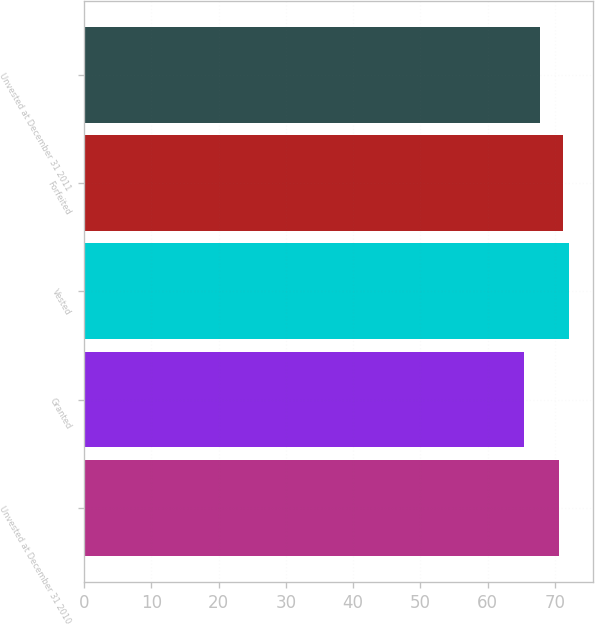Convert chart. <chart><loc_0><loc_0><loc_500><loc_500><bar_chart><fcel>Unvested at December 31 2010<fcel>Granted<fcel>Vested<fcel>Forfeited<fcel>Unvested at December 31 2011<nl><fcel>70.6<fcel>65.4<fcel>72.05<fcel>71.26<fcel>67.85<nl></chart> 